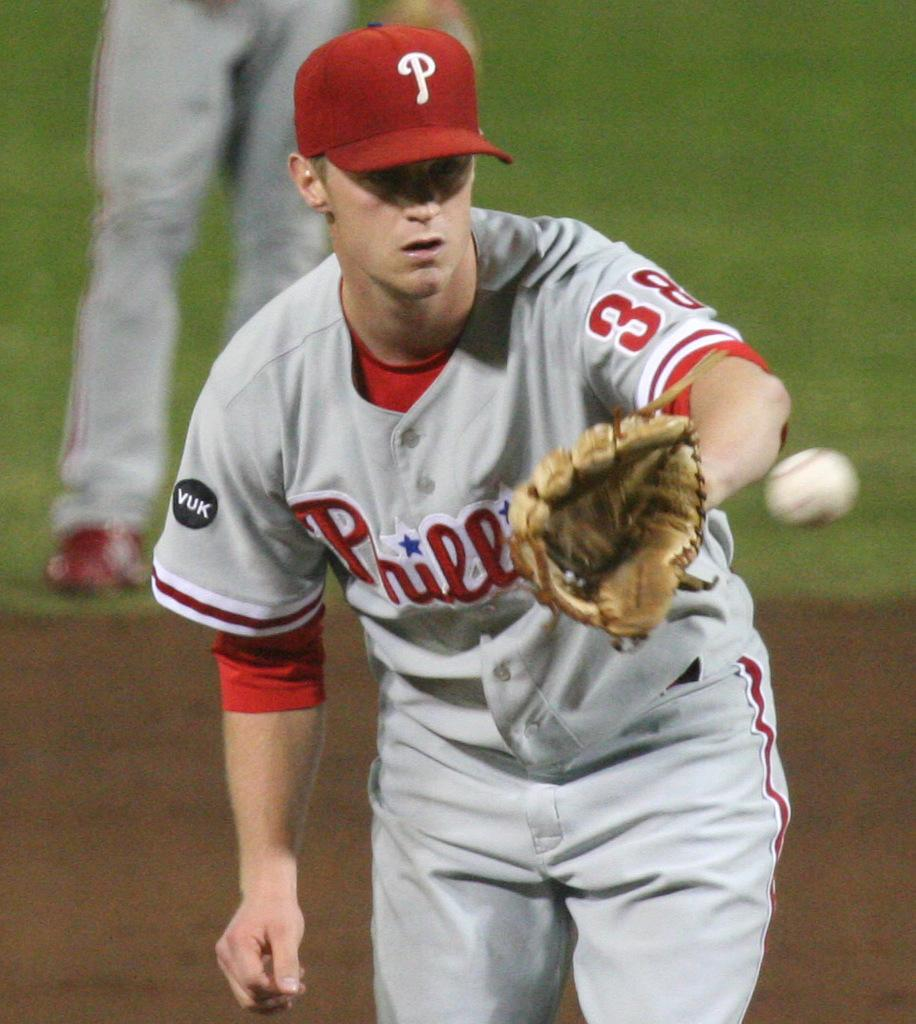Who or what is present in the image? There is a person in the image. What is the person wearing? The person is wearing clothes and a glove. What object can be seen on the right side of the image? There is a ball on the right side of the image. Where are the person's legs visible in the image? The person's legs are visible in the top left of the image. What type of polish is the person applying to their throat in the image? There is no indication in the image that the person is applying any polish to their throat. 